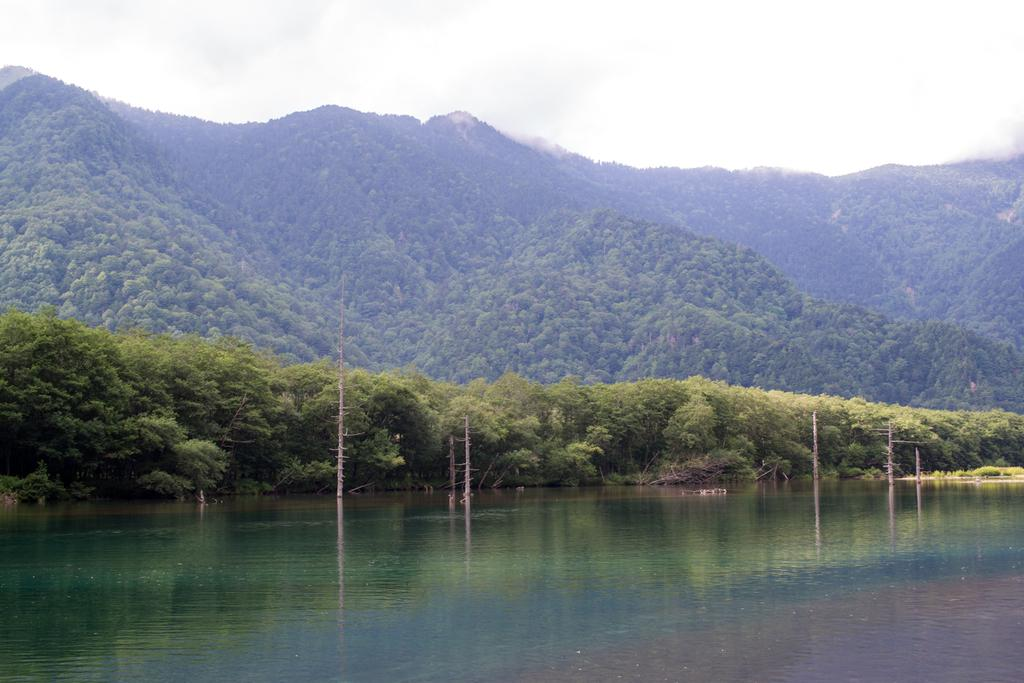What is the primary element visible in the image? There is water in the image. What structures can be seen in the image? There are poles in the image. What type of vegetation is present in the image? There are trees in the image. What can be seen in the distance in the image? There is a mountain in the background of the image. What is visible above the mountain in the image? The sky is visible in the background of the image. What type of paste is being used to hold the suit together in the image? There is no suit or paste present in the image; it features water, poles, trees, a mountain, and the sky. 